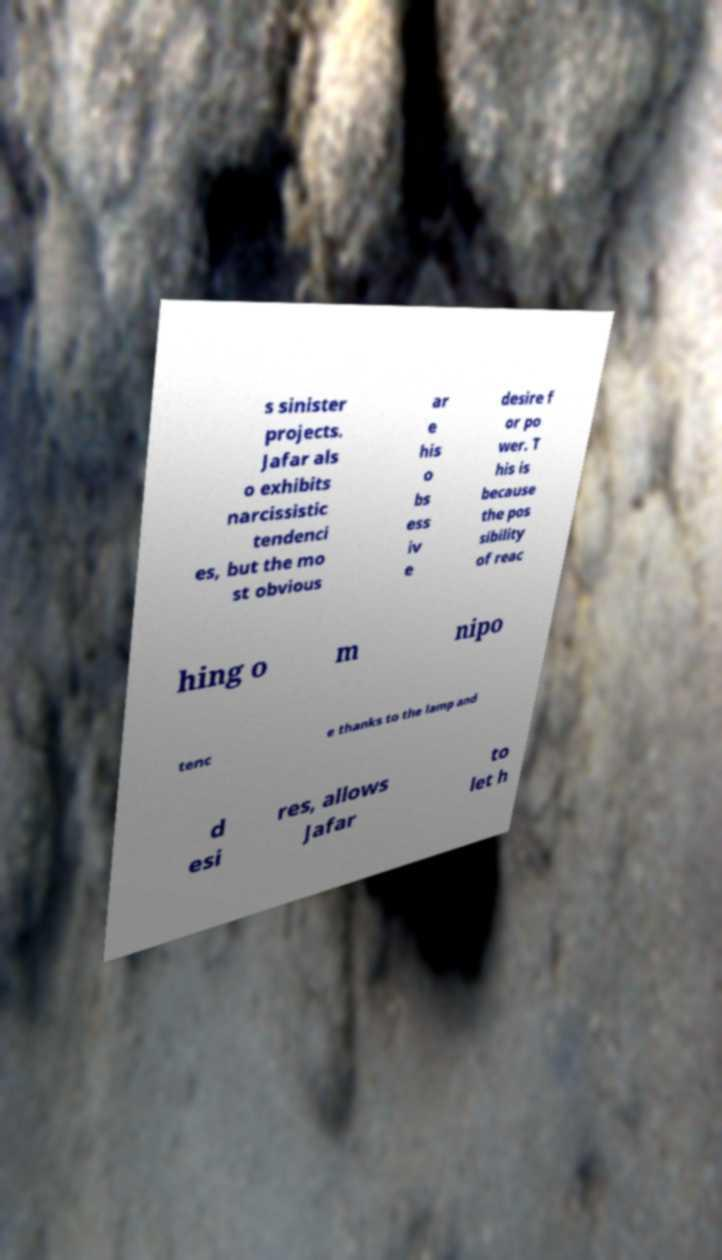What messages or text are displayed in this image? I need them in a readable, typed format. s sinister projects. Jafar als o exhibits narcissistic tendenci es, but the mo st obvious ar e his o bs ess iv e desire f or po wer. T his is because the pos sibility of reac hing o m nipo tenc e thanks to the lamp and d esi res, allows Jafar to let h 